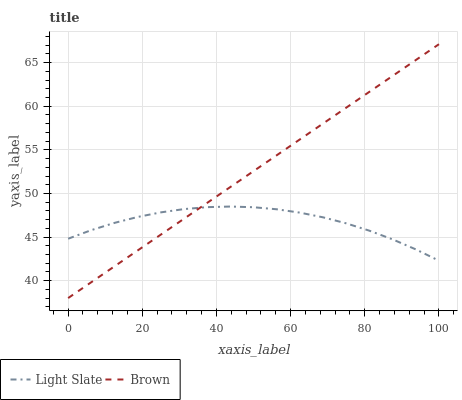Does Light Slate have the minimum area under the curve?
Answer yes or no. Yes. Does Brown have the maximum area under the curve?
Answer yes or no. Yes. Does Brown have the minimum area under the curve?
Answer yes or no. No. Is Brown the smoothest?
Answer yes or no. Yes. Is Light Slate the roughest?
Answer yes or no. Yes. Is Brown the roughest?
Answer yes or no. No. Does Brown have the lowest value?
Answer yes or no. Yes. Does Brown have the highest value?
Answer yes or no. Yes. Does Brown intersect Light Slate?
Answer yes or no. Yes. Is Brown less than Light Slate?
Answer yes or no. No. Is Brown greater than Light Slate?
Answer yes or no. No. 